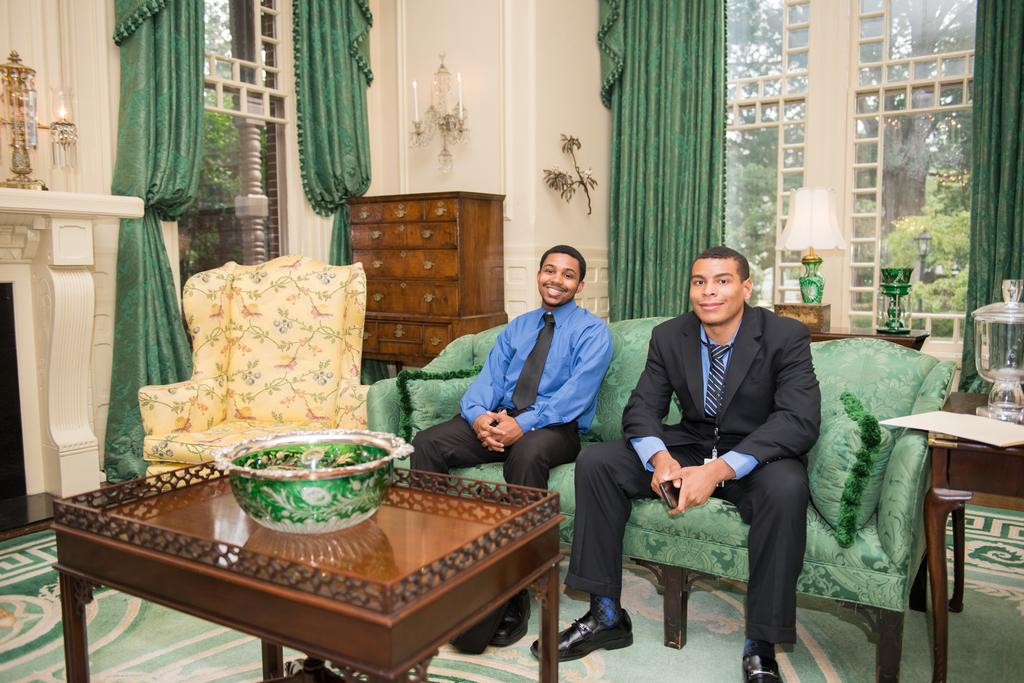How many people are in the image? There are two men in the image. What are the men doing in the image? The men are sitting on a couch and smiling. What can be seen in the background of the image? There is a custom in the background of the image, as well as a lamp. How many fingers does the man on the left have in the image? There is no information about the number of fingers the men have in the image. --- Facts: 1. There is a car in the image. 2. The car is red. 3. The car has four wheels. 4. There is a road in the image. 5. The road is paved. Absurd Topics: dance, ocean, bird Conversation: What is the main subject of the image? The main subject of the image is a car. What color is the car? The car is red. How many wheels does the car have? The car has four wheels. What can be seen in the background of the image? There is a road in the image. What is the condition of the road? The road is paved. Reasoning: Let's think step by step in order to produce the conversation. We start by identifying the main subject of the image, which is the car. Then, we describe the car's color and the number of wheels it has. Next, we mention the background element, which is the road. Finally, we provide information about the road's condition, noting that it is paved. Absurd Question/Answer: Can you see any birds flying over the ocean in the image? There is no ocean or birds present in the image; it features a red car and a paved road. 